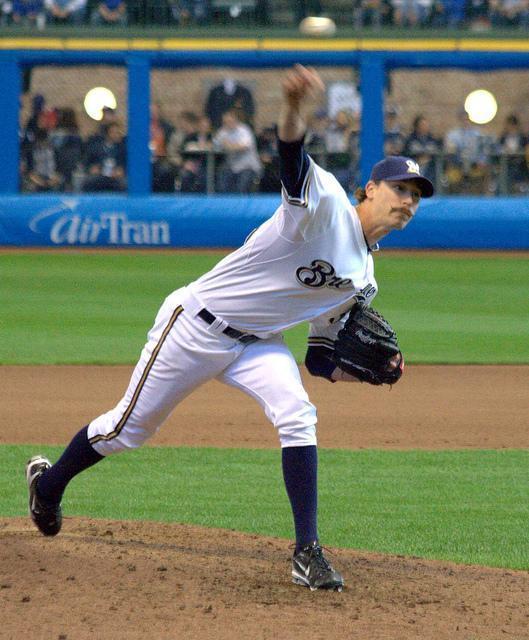How many people are there?
Give a very brief answer. 4. 